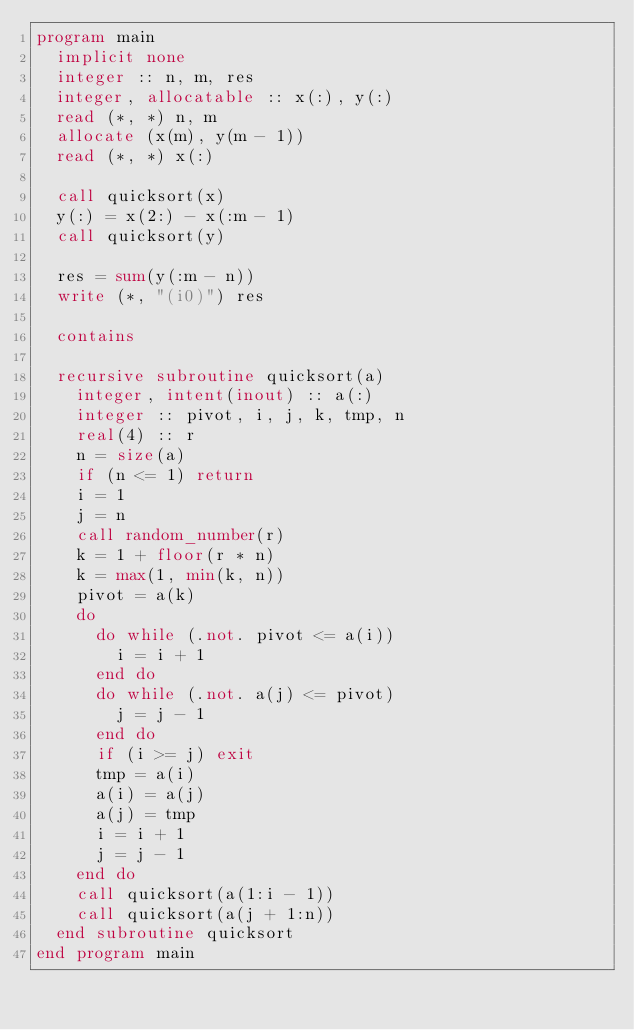Convert code to text. <code><loc_0><loc_0><loc_500><loc_500><_FORTRAN_>program main
  implicit none
  integer :: n, m, res
  integer, allocatable :: x(:), y(:)
  read (*, *) n, m
  allocate (x(m), y(m - 1))
  read (*, *) x(:)

  call quicksort(x)
  y(:) = x(2:) - x(:m - 1)
  call quicksort(y)

  res = sum(y(:m - n))
  write (*, "(i0)") res

  contains

  recursive subroutine quicksort(a)
    integer, intent(inout) :: a(:)
    integer :: pivot, i, j, k, tmp, n
    real(4) :: r
    n = size(a)
    if (n <= 1) return
    i = 1
    j = n
    call random_number(r)
    k = 1 + floor(r * n)
    k = max(1, min(k, n))
    pivot = a(k)
    do
      do while (.not. pivot <= a(i))
        i = i + 1
      end do
      do while (.not. a(j) <= pivot)
        j = j - 1
      end do
      if (i >= j) exit
      tmp = a(i)
      a(i) = a(j)
      a(j) = tmp
      i = i + 1
      j = j - 1
    end do
    call quicksort(a(1:i - 1))
    call quicksort(a(j + 1:n))
  end subroutine quicksort
end program main
</code> 